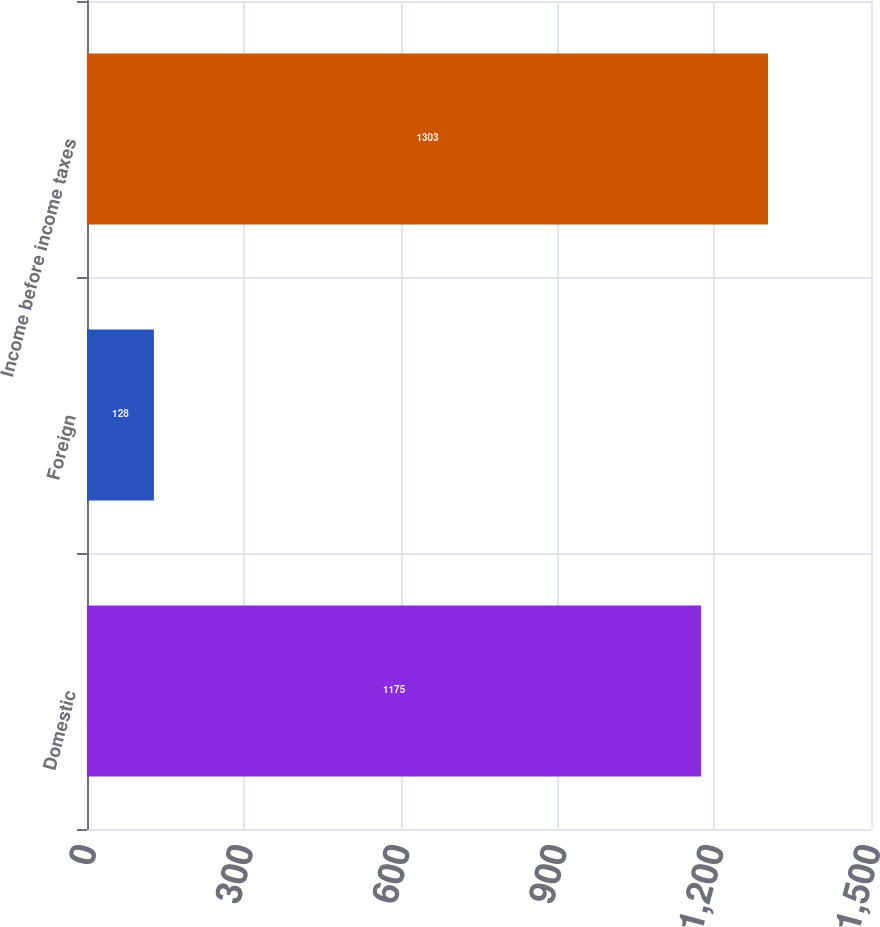Convert chart to OTSL. <chart><loc_0><loc_0><loc_500><loc_500><bar_chart><fcel>Domestic<fcel>Foreign<fcel>Income before income taxes<nl><fcel>1175<fcel>128<fcel>1303<nl></chart> 